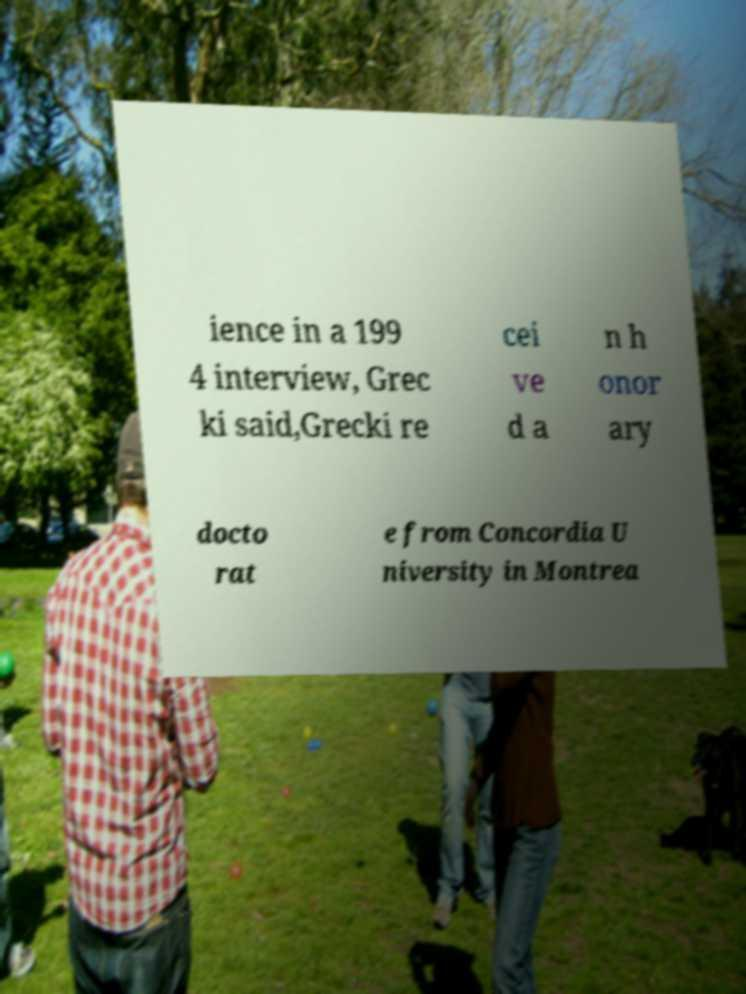What messages or text are displayed in this image? I need them in a readable, typed format. ience in a 199 4 interview, Grec ki said,Grecki re cei ve d a n h onor ary docto rat e from Concordia U niversity in Montrea 